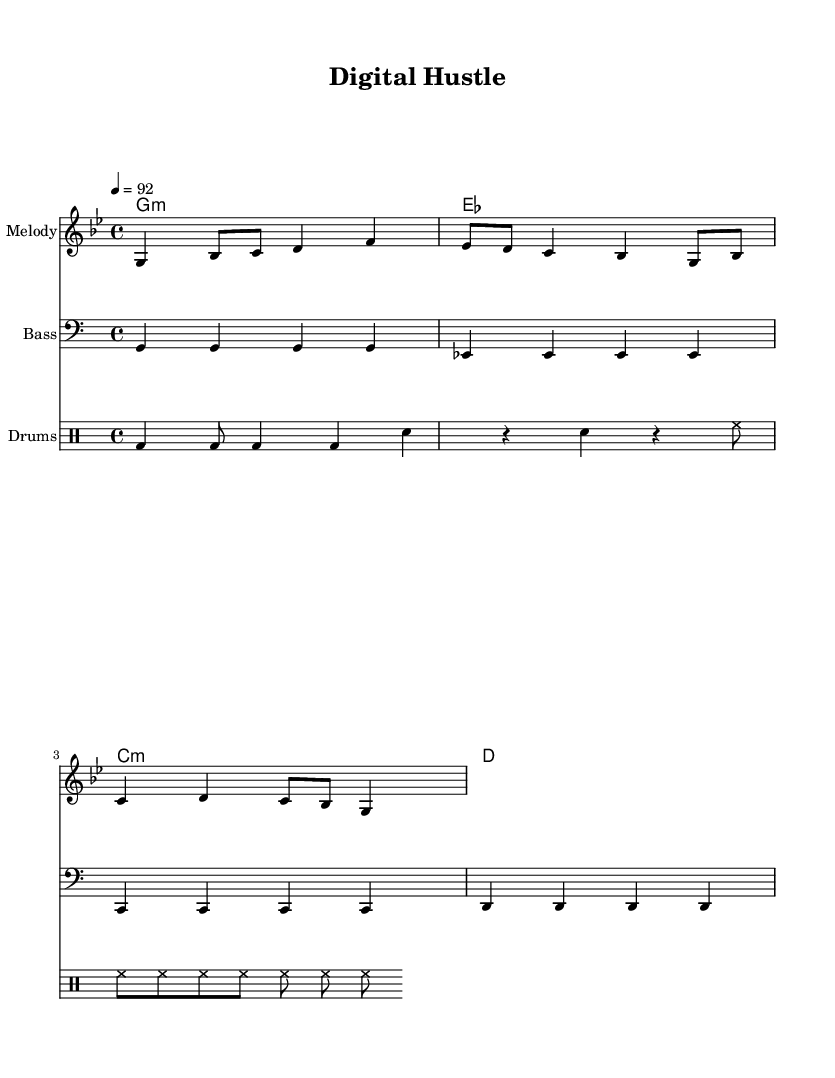What is the key signature of this music? The key signature indicated at the beginning of the piece specifies G minor, which has two flats (B flat and E flat). This can be verified by examining the key signature section in the staff where the sharps and flats are notated.
Answer: G minor What is the time signature of the piece? The time signature shown at the beginning is 4/4, meaning there are four beats in each measure and the quarter note receives one beat. This is indicated right after the key signature in the music sheet.
Answer: 4/4 What is the tempo marking for this piece? The tempo marking, which indicates the speed of the piece, is noted as 4 = 92, meaning there are 92 beats per minute for the quarter note. This can be confirmed by looking at the tempo line at the start of the score.
Answer: 92 How many measures are there in the melody? Counting the sets of notes in the melody staff, there are four distinct measures, as each group of notes separated by vertical lines represents a measure. This is visually confirmed by checking the measure divisions in the notation.
Answer: 4 What type of lyrics are included in this composition? The lyrics provided match the melody and represent a motivational theme related to the digital age and innovation, as indicated in the text area of the sheet music. The structure follows typical lyric formatting which corresponds with the melodic lines.
Answer: Motivational Which instruments are used in the score? The instruments featured in the score include melody, bass, and drums, as indicated by the different staves labeled accordingly. Each staff represents a different instrument's part in the arrangement of the composition.
Answer: Melody, Bass, Drums What genre does this song belong to? This song falls under the genre of hip-hop, characterized by its rhythmic vocal style and motivational themes about entrepreneurship, as suggested by the title "Digital Hustle" and the context of the lyrics.
Answer: Hip-hop 